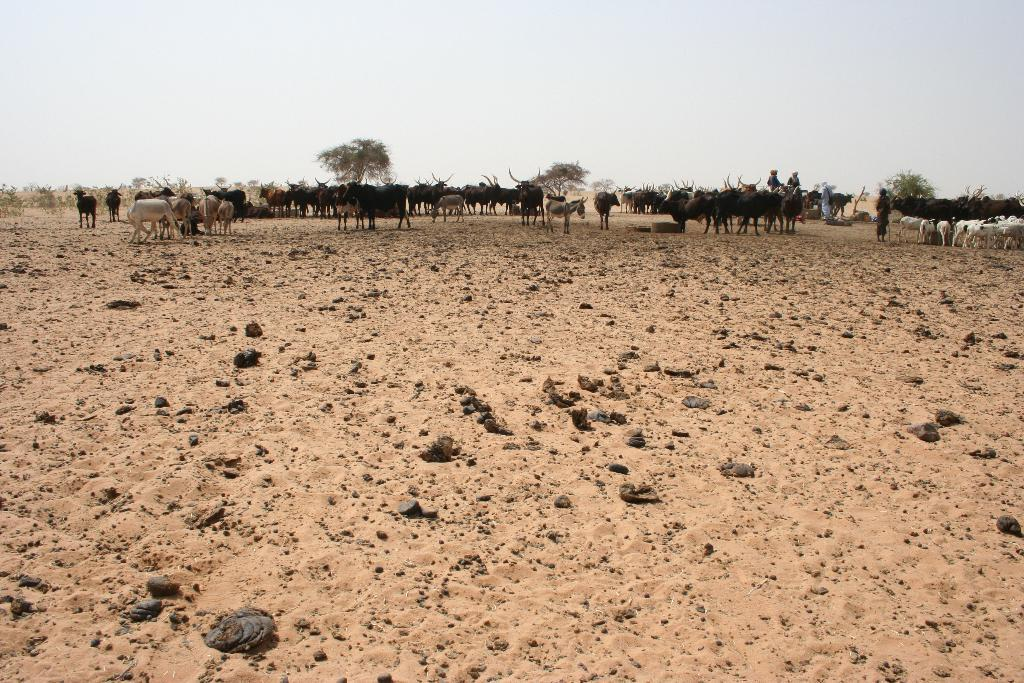What types of living organisms are present on the surface in the image? There are animals on the surface in the image. Can you describe the people in the image? There are people in the image. What type of vegetation is present in the image? There are trees in the image. What can be seen in the sky in the image? Clouds are visible in the sky in the image. Where is the bird's nest located in the image? There is no bird's nest present in the image. What type of van can be seen parked near the trees in the image? There is no van present in the image. 